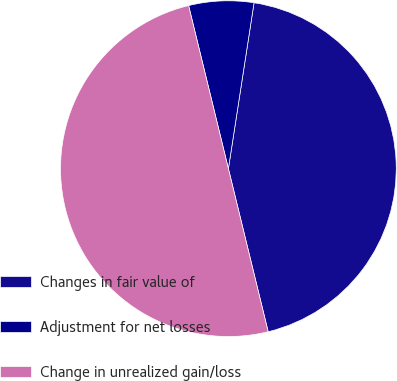Convert chart. <chart><loc_0><loc_0><loc_500><loc_500><pie_chart><fcel>Changes in fair value of<fcel>Adjustment for net losses<fcel>Change in unrealized gain/loss<nl><fcel>43.75%<fcel>6.25%<fcel>50.0%<nl></chart> 